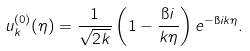Convert formula to latex. <formula><loc_0><loc_0><loc_500><loc_500>u _ { k } ^ { ( 0 ) } ( \eta ) = \frac { 1 } { \sqrt { 2 k } } \left ( 1 - \frac { \i i } { k \eta } \right ) e ^ { - \i i k \eta } .</formula> 